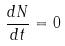<formula> <loc_0><loc_0><loc_500><loc_500>\frac { d N } { d t } = 0</formula> 